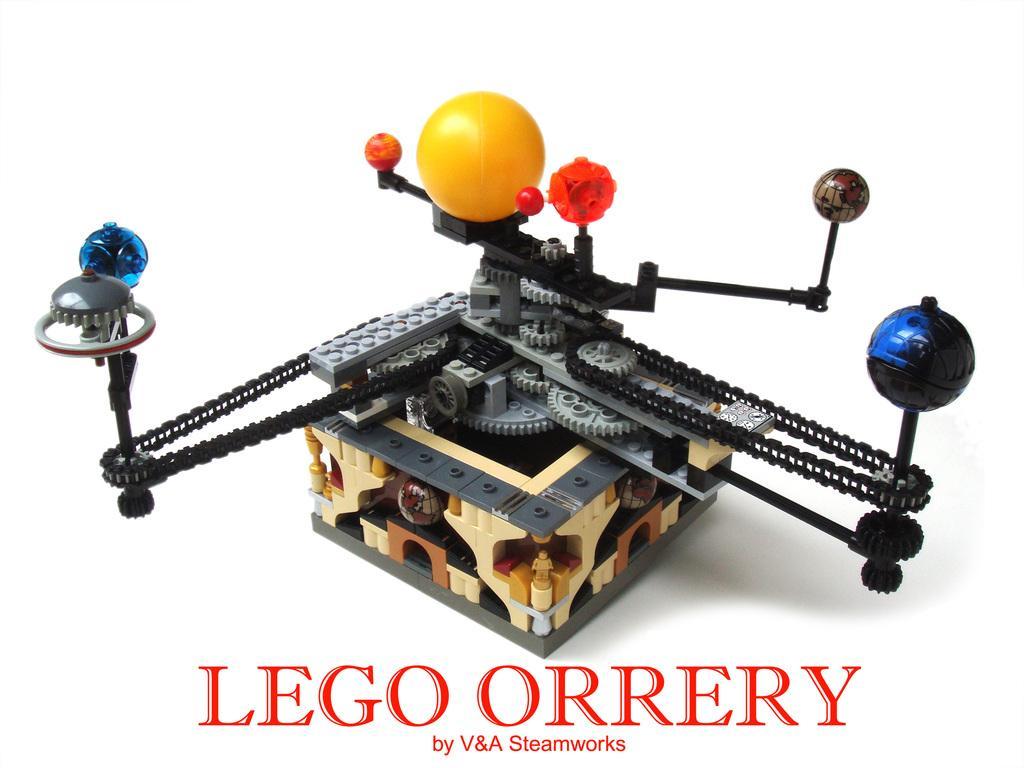How would you summarize this image in a sentence or two? This picture contains a solar system rotating model. At the bottom of the picture, it is written as "LEGO ORRERY". In the background, it is white in color. 